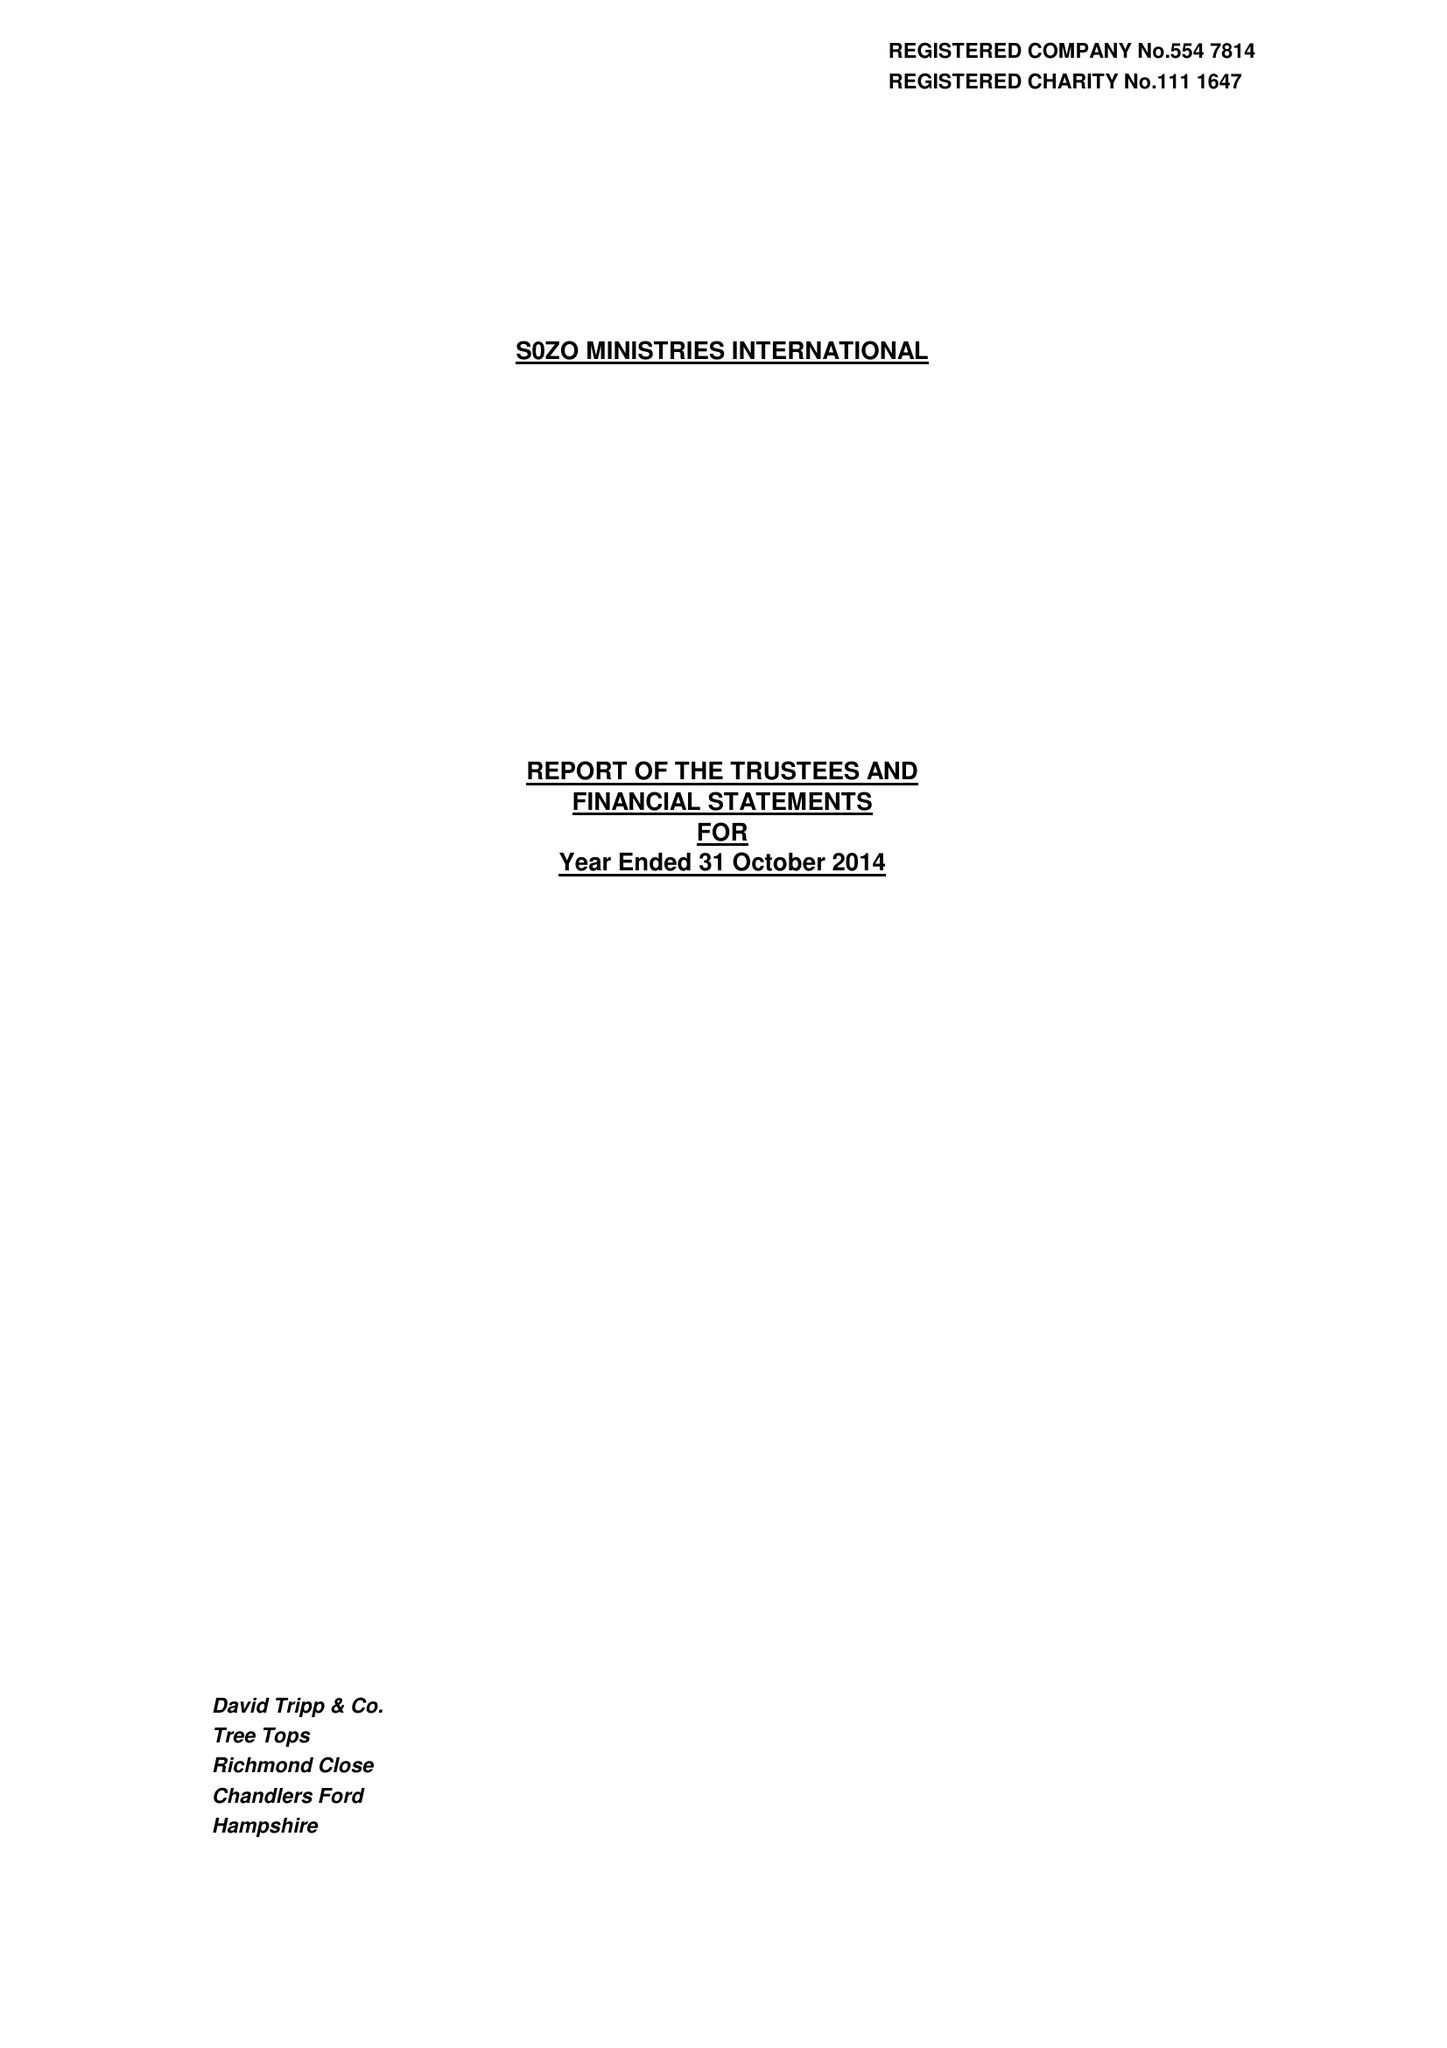What is the value for the address__street_line?
Answer the question using a single word or phrase. DANES ROAD 